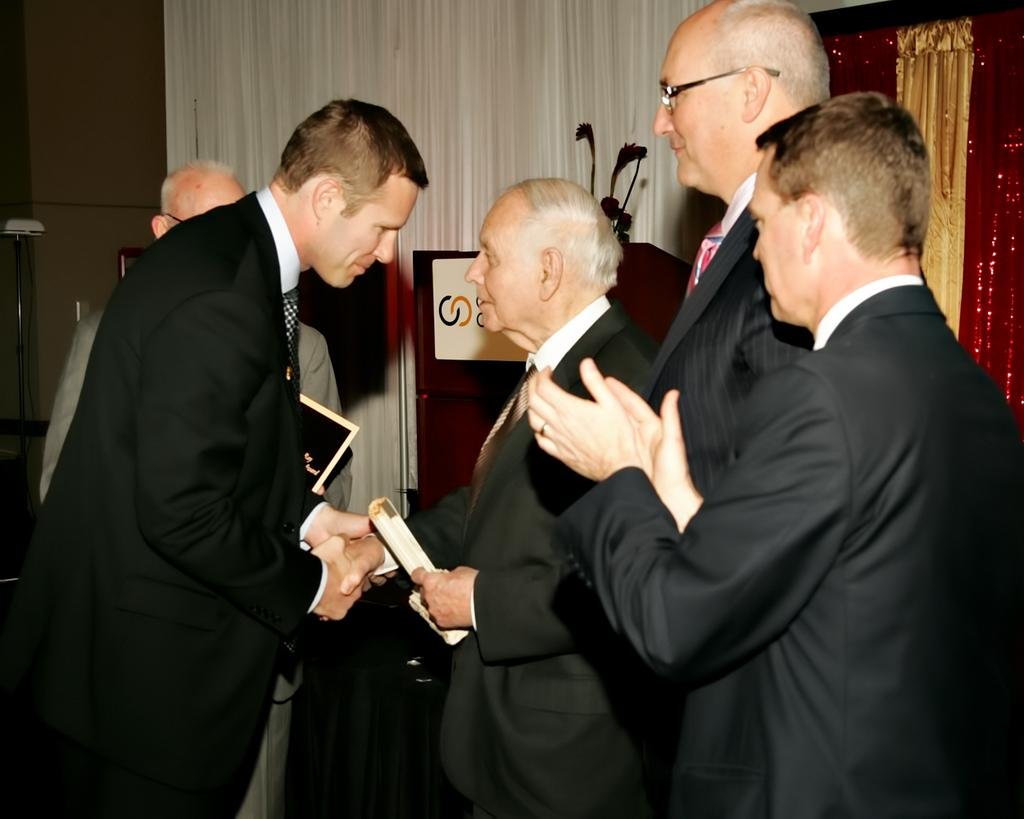What are the people in the image wearing? The people in the image are wearing suits. What action are the two people in the image performing? Two people are giving a handshake. What object can be seen in the image that is often used for speeches or presentations? There is a podium in the image. What type of window treatment is present in the image? There are curtains in the image. What book is the person reading during the rainstorm in the image? There is no book or rainstorm present in the image; it features people in suits, a handshake, a podium, and curtains. 